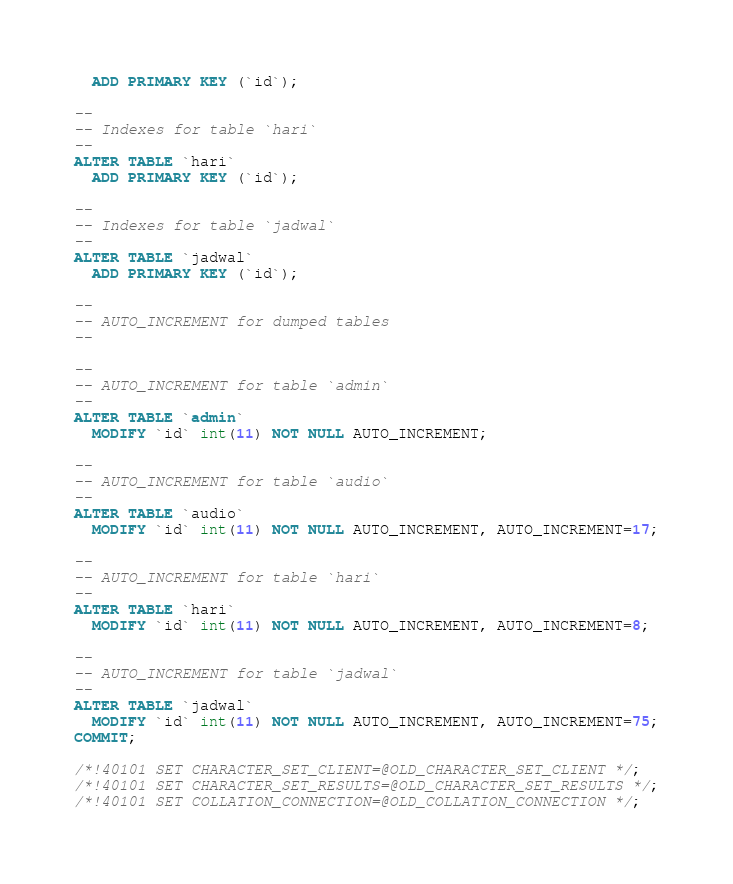<code> <loc_0><loc_0><loc_500><loc_500><_SQL_>  ADD PRIMARY KEY (`id`);

--
-- Indexes for table `hari`
--
ALTER TABLE `hari`
  ADD PRIMARY KEY (`id`);

--
-- Indexes for table `jadwal`
--
ALTER TABLE `jadwal`
  ADD PRIMARY KEY (`id`);

--
-- AUTO_INCREMENT for dumped tables
--

--
-- AUTO_INCREMENT for table `admin`
--
ALTER TABLE `admin`
  MODIFY `id` int(11) NOT NULL AUTO_INCREMENT;

--
-- AUTO_INCREMENT for table `audio`
--
ALTER TABLE `audio`
  MODIFY `id` int(11) NOT NULL AUTO_INCREMENT, AUTO_INCREMENT=17;

--
-- AUTO_INCREMENT for table `hari`
--
ALTER TABLE `hari`
  MODIFY `id` int(11) NOT NULL AUTO_INCREMENT, AUTO_INCREMENT=8;

--
-- AUTO_INCREMENT for table `jadwal`
--
ALTER TABLE `jadwal`
  MODIFY `id` int(11) NOT NULL AUTO_INCREMENT, AUTO_INCREMENT=75;
COMMIT;

/*!40101 SET CHARACTER_SET_CLIENT=@OLD_CHARACTER_SET_CLIENT */;
/*!40101 SET CHARACTER_SET_RESULTS=@OLD_CHARACTER_SET_RESULTS */;
/*!40101 SET COLLATION_CONNECTION=@OLD_COLLATION_CONNECTION */;
</code> 